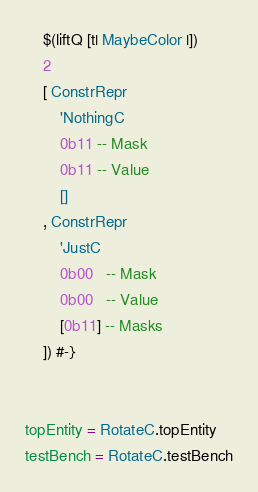<code> <loc_0><loc_0><loc_500><loc_500><_Haskell_>    $(liftQ [t| MaybeColor |])
    2
    [ ConstrRepr
        'NothingC
        0b11 -- Mask
        0b11 -- Value
        []
    , ConstrRepr
        'JustC
        0b00   -- Mask
        0b00   -- Value
        [0b11] -- Masks
    ]) #-}


topEntity = RotateC.topEntity
testBench = RotateC.testBench
</code> 